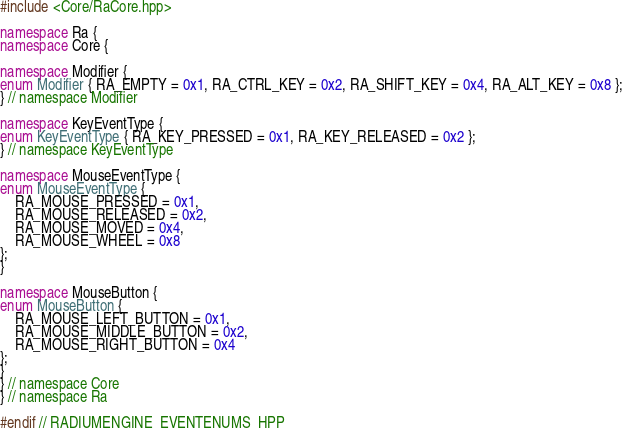<code> <loc_0><loc_0><loc_500><loc_500><_C++_>#include <Core/RaCore.hpp>

namespace Ra {
namespace Core {

namespace Modifier {
enum Modifier { RA_EMPTY = 0x1, RA_CTRL_KEY = 0x2, RA_SHIFT_KEY = 0x4, RA_ALT_KEY = 0x8 };
} // namespace Modifier

namespace KeyEventType {
enum KeyEventType { RA_KEY_PRESSED = 0x1, RA_KEY_RELEASED = 0x2 };
} // namespace KeyEventType

namespace MouseEventType {
enum MouseEventType {
    RA_MOUSE_PRESSED = 0x1,
    RA_MOUSE_RELEASED = 0x2,
    RA_MOUSE_MOVED = 0x4,
    RA_MOUSE_WHEEL = 0x8
};
}

namespace MouseButton {
enum MouseButton {
    RA_MOUSE_LEFT_BUTTON = 0x1,
    RA_MOUSE_MIDDLE_BUTTON = 0x2,
    RA_MOUSE_RIGHT_BUTTON = 0x4
};
}
} // namespace Core
} // namespace Ra

#endif // RADIUMENGINE_EVENTENUMS_HPP
</code> 